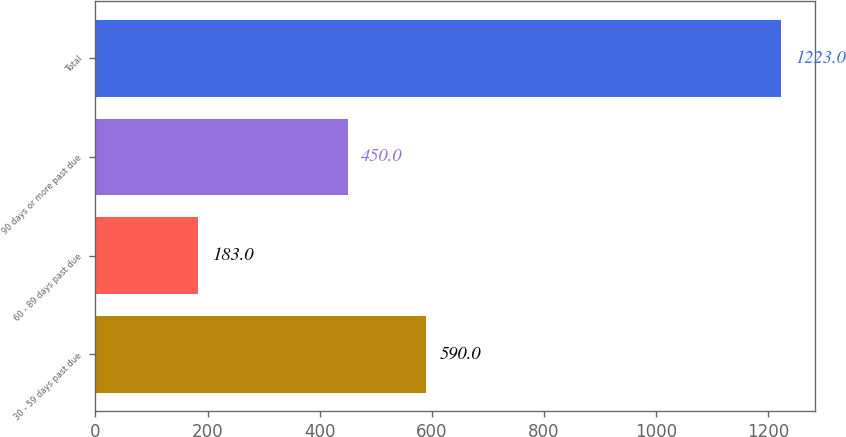Convert chart. <chart><loc_0><loc_0><loc_500><loc_500><bar_chart><fcel>30 - 59 days past due<fcel>60 - 89 days past due<fcel>90 days or more past due<fcel>Total<nl><fcel>590<fcel>183<fcel>450<fcel>1223<nl></chart> 